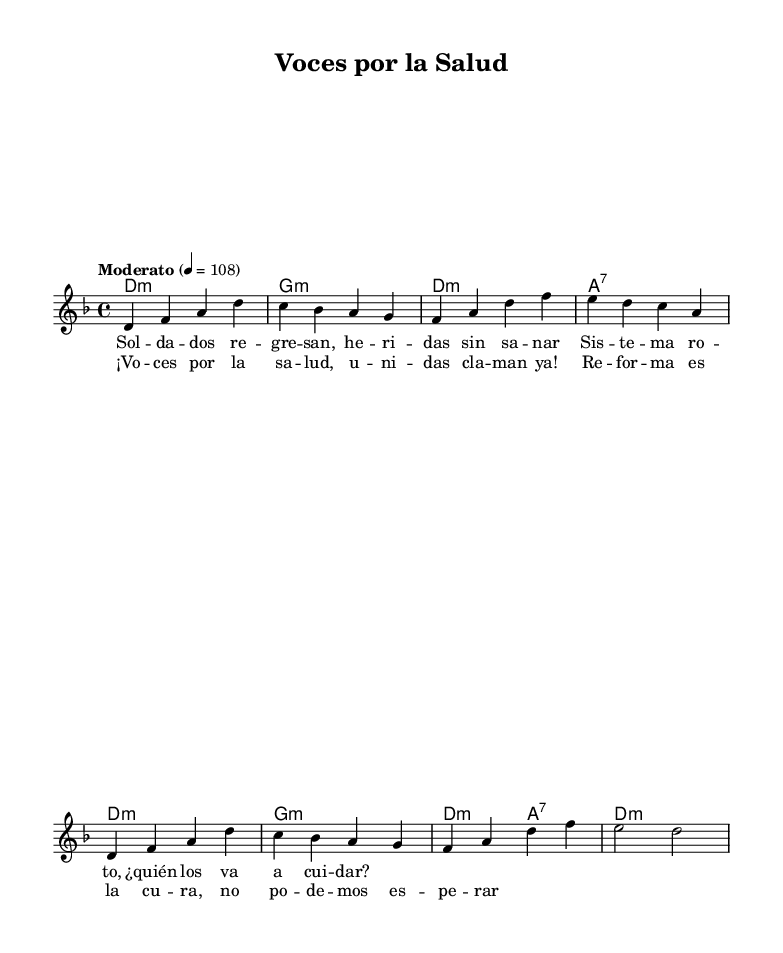What is the key signature of this music? The key signature is represented by the symbol at the beginning of the staff. In this case, there is one flat, indicating that the piece is in D minor.
Answer: D minor What is the time signature of this piece? The time signature is found at the beginning of the music, represented by the numbers stacked over each other. Here, it shows 4 over 4, which indicates there are four beats in each measure.
Answer: 4/4 What is the tempo marking for the piece? The tempo marking is indicated in text format. In this music sheet, it states "Moderato" followed by a number representing beats per minute, which is 108.
Answer: Moderato, 108 How many measures are in the melody section? To determine the number of measures, we count the vertical lines that indicate the end of each measure in the melody. There are a total of 8 measures in the melody section.
Answer: 8 What theme is highlighted in the lyrics of the song? By reading the provided lyrics, we can identify that the song addresses issues related to health and social justice, indicated by phrases like "Voces por la salud" and "Reforma es la cura."
Answer: Healthcare and social issues Which part of the music contains the chorus? The chorus is identifiable as the section of lyrics that follows the first set of verses and is typically characterized by repetition and thematic prominence. In this sheet music, it is found after the verse section.
Answer: After the verse What type of harmony does the piece use? The chords in the chord mode indicate a minor key with a mix of minor and seventh chords, typical in Latin American protest songs, enhancing the emotional depth. The chords indicate D minor and G minor among others.
Answer: Minor and seventh chords 